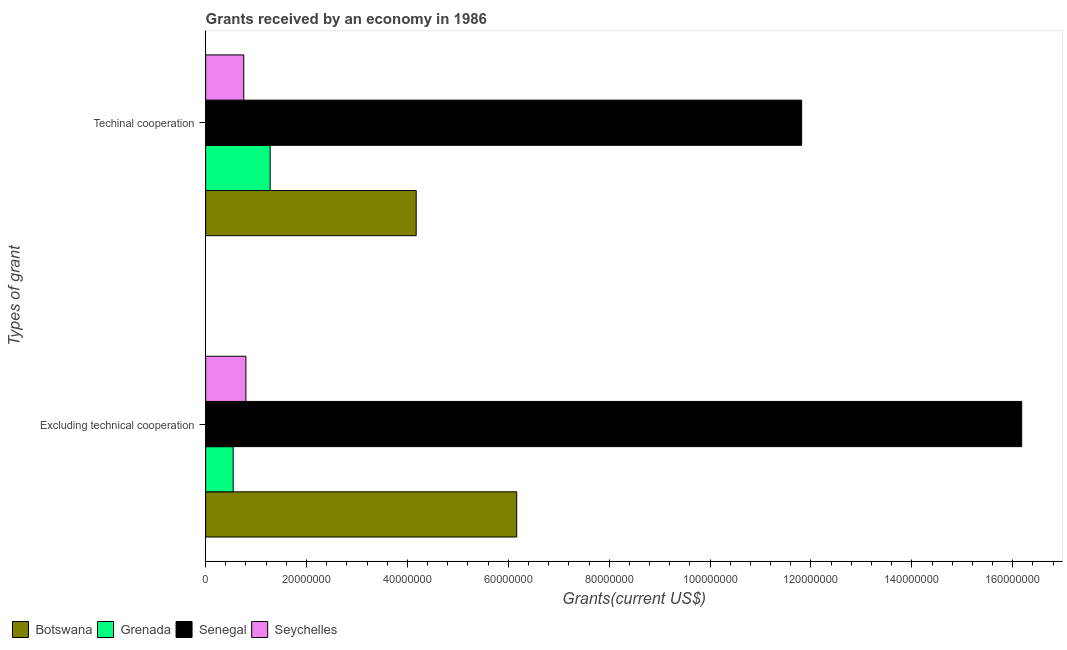How many different coloured bars are there?
Make the answer very short. 4. How many groups of bars are there?
Ensure brevity in your answer.  2. Are the number of bars on each tick of the Y-axis equal?
Provide a short and direct response. Yes. How many bars are there on the 2nd tick from the top?
Ensure brevity in your answer.  4. What is the label of the 1st group of bars from the top?
Your answer should be compact. Techinal cooperation. What is the amount of grants received(including technical cooperation) in Grenada?
Offer a terse response. 1.28e+07. Across all countries, what is the maximum amount of grants received(excluding technical cooperation)?
Offer a very short reply. 1.62e+08. Across all countries, what is the minimum amount of grants received(excluding technical cooperation)?
Give a very brief answer. 5.46e+06. In which country was the amount of grants received(including technical cooperation) maximum?
Provide a short and direct response. Senegal. In which country was the amount of grants received(excluding technical cooperation) minimum?
Your answer should be compact. Grenada. What is the total amount of grants received(including technical cooperation) in the graph?
Your response must be concise. 1.80e+08. What is the difference between the amount of grants received(excluding technical cooperation) in Grenada and that in Senegal?
Offer a terse response. -1.56e+08. What is the difference between the amount of grants received(excluding technical cooperation) in Grenada and the amount of grants received(including technical cooperation) in Senegal?
Your response must be concise. -1.13e+08. What is the average amount of grants received(excluding technical cooperation) per country?
Make the answer very short. 5.92e+07. What is the difference between the amount of grants received(including technical cooperation) and amount of grants received(excluding technical cooperation) in Seychelles?
Provide a short and direct response. -4.20e+05. What is the ratio of the amount of grants received(including technical cooperation) in Seychelles to that in Grenada?
Keep it short and to the point. 0.59. Is the amount of grants received(excluding technical cooperation) in Botswana less than that in Grenada?
Make the answer very short. No. In how many countries, is the amount of grants received(excluding technical cooperation) greater than the average amount of grants received(excluding technical cooperation) taken over all countries?
Ensure brevity in your answer.  2. What does the 3rd bar from the top in Excluding technical cooperation represents?
Your response must be concise. Grenada. What does the 4th bar from the bottom in Techinal cooperation represents?
Offer a very short reply. Seychelles. How many bars are there?
Keep it short and to the point. 8. Does the graph contain any zero values?
Your response must be concise. No. Does the graph contain grids?
Your response must be concise. No. How many legend labels are there?
Provide a succinct answer. 4. How are the legend labels stacked?
Ensure brevity in your answer.  Horizontal. What is the title of the graph?
Ensure brevity in your answer.  Grants received by an economy in 1986. What is the label or title of the X-axis?
Your answer should be very brief. Grants(current US$). What is the label or title of the Y-axis?
Keep it short and to the point. Types of grant. What is the Grants(current US$) in Botswana in Excluding technical cooperation?
Keep it short and to the point. 6.17e+07. What is the Grants(current US$) of Grenada in Excluding technical cooperation?
Provide a short and direct response. 5.46e+06. What is the Grants(current US$) of Senegal in Excluding technical cooperation?
Your response must be concise. 1.62e+08. What is the Grants(current US$) of Seychelles in Excluding technical cooperation?
Your answer should be very brief. 7.98e+06. What is the Grants(current US$) in Botswana in Techinal cooperation?
Ensure brevity in your answer.  4.17e+07. What is the Grants(current US$) in Grenada in Techinal cooperation?
Your answer should be compact. 1.28e+07. What is the Grants(current US$) of Senegal in Techinal cooperation?
Ensure brevity in your answer.  1.18e+08. What is the Grants(current US$) of Seychelles in Techinal cooperation?
Make the answer very short. 7.56e+06. Across all Types of grant, what is the maximum Grants(current US$) in Botswana?
Your response must be concise. 6.17e+07. Across all Types of grant, what is the maximum Grants(current US$) in Grenada?
Offer a terse response. 1.28e+07. Across all Types of grant, what is the maximum Grants(current US$) of Senegal?
Keep it short and to the point. 1.62e+08. Across all Types of grant, what is the maximum Grants(current US$) in Seychelles?
Ensure brevity in your answer.  7.98e+06. Across all Types of grant, what is the minimum Grants(current US$) of Botswana?
Offer a terse response. 4.17e+07. Across all Types of grant, what is the minimum Grants(current US$) of Grenada?
Your answer should be very brief. 5.46e+06. Across all Types of grant, what is the minimum Grants(current US$) in Senegal?
Offer a very short reply. 1.18e+08. Across all Types of grant, what is the minimum Grants(current US$) of Seychelles?
Provide a succinct answer. 7.56e+06. What is the total Grants(current US$) in Botswana in the graph?
Keep it short and to the point. 1.03e+08. What is the total Grants(current US$) of Grenada in the graph?
Your answer should be compact. 1.82e+07. What is the total Grants(current US$) of Senegal in the graph?
Give a very brief answer. 2.80e+08. What is the total Grants(current US$) of Seychelles in the graph?
Give a very brief answer. 1.55e+07. What is the difference between the Grants(current US$) in Botswana in Excluding technical cooperation and that in Techinal cooperation?
Keep it short and to the point. 1.99e+07. What is the difference between the Grants(current US$) of Grenada in Excluding technical cooperation and that in Techinal cooperation?
Make the answer very short. -7.33e+06. What is the difference between the Grants(current US$) of Senegal in Excluding technical cooperation and that in Techinal cooperation?
Offer a very short reply. 4.36e+07. What is the difference between the Grants(current US$) in Botswana in Excluding technical cooperation and the Grants(current US$) in Grenada in Techinal cooperation?
Your response must be concise. 4.89e+07. What is the difference between the Grants(current US$) in Botswana in Excluding technical cooperation and the Grants(current US$) in Senegal in Techinal cooperation?
Provide a short and direct response. -5.65e+07. What is the difference between the Grants(current US$) of Botswana in Excluding technical cooperation and the Grants(current US$) of Seychelles in Techinal cooperation?
Provide a succinct answer. 5.41e+07. What is the difference between the Grants(current US$) of Grenada in Excluding technical cooperation and the Grants(current US$) of Senegal in Techinal cooperation?
Ensure brevity in your answer.  -1.13e+08. What is the difference between the Grants(current US$) of Grenada in Excluding technical cooperation and the Grants(current US$) of Seychelles in Techinal cooperation?
Give a very brief answer. -2.10e+06. What is the difference between the Grants(current US$) of Senegal in Excluding technical cooperation and the Grants(current US$) of Seychelles in Techinal cooperation?
Give a very brief answer. 1.54e+08. What is the average Grants(current US$) in Botswana per Types of grant?
Your answer should be compact. 5.17e+07. What is the average Grants(current US$) in Grenada per Types of grant?
Make the answer very short. 9.12e+06. What is the average Grants(current US$) in Senegal per Types of grant?
Your response must be concise. 1.40e+08. What is the average Grants(current US$) of Seychelles per Types of grant?
Keep it short and to the point. 7.77e+06. What is the difference between the Grants(current US$) of Botswana and Grants(current US$) of Grenada in Excluding technical cooperation?
Provide a short and direct response. 5.62e+07. What is the difference between the Grants(current US$) in Botswana and Grants(current US$) in Senegal in Excluding technical cooperation?
Your answer should be very brief. -1.00e+08. What is the difference between the Grants(current US$) of Botswana and Grants(current US$) of Seychelles in Excluding technical cooperation?
Make the answer very short. 5.37e+07. What is the difference between the Grants(current US$) in Grenada and Grants(current US$) in Senegal in Excluding technical cooperation?
Your answer should be very brief. -1.56e+08. What is the difference between the Grants(current US$) of Grenada and Grants(current US$) of Seychelles in Excluding technical cooperation?
Make the answer very short. -2.52e+06. What is the difference between the Grants(current US$) in Senegal and Grants(current US$) in Seychelles in Excluding technical cooperation?
Ensure brevity in your answer.  1.54e+08. What is the difference between the Grants(current US$) in Botswana and Grants(current US$) in Grenada in Techinal cooperation?
Keep it short and to the point. 2.90e+07. What is the difference between the Grants(current US$) in Botswana and Grants(current US$) in Senegal in Techinal cooperation?
Provide a succinct answer. -7.64e+07. What is the difference between the Grants(current US$) in Botswana and Grants(current US$) in Seychelles in Techinal cooperation?
Offer a terse response. 3.42e+07. What is the difference between the Grants(current US$) of Grenada and Grants(current US$) of Senegal in Techinal cooperation?
Your answer should be compact. -1.05e+08. What is the difference between the Grants(current US$) of Grenada and Grants(current US$) of Seychelles in Techinal cooperation?
Provide a short and direct response. 5.23e+06. What is the difference between the Grants(current US$) in Senegal and Grants(current US$) in Seychelles in Techinal cooperation?
Give a very brief answer. 1.11e+08. What is the ratio of the Grants(current US$) in Botswana in Excluding technical cooperation to that in Techinal cooperation?
Ensure brevity in your answer.  1.48. What is the ratio of the Grants(current US$) in Grenada in Excluding technical cooperation to that in Techinal cooperation?
Give a very brief answer. 0.43. What is the ratio of the Grants(current US$) of Senegal in Excluding technical cooperation to that in Techinal cooperation?
Your answer should be very brief. 1.37. What is the ratio of the Grants(current US$) in Seychelles in Excluding technical cooperation to that in Techinal cooperation?
Offer a very short reply. 1.06. What is the difference between the highest and the second highest Grants(current US$) in Botswana?
Give a very brief answer. 1.99e+07. What is the difference between the highest and the second highest Grants(current US$) in Grenada?
Make the answer very short. 7.33e+06. What is the difference between the highest and the second highest Grants(current US$) in Senegal?
Your answer should be very brief. 4.36e+07. What is the difference between the highest and the lowest Grants(current US$) in Botswana?
Your answer should be compact. 1.99e+07. What is the difference between the highest and the lowest Grants(current US$) of Grenada?
Offer a very short reply. 7.33e+06. What is the difference between the highest and the lowest Grants(current US$) of Senegal?
Keep it short and to the point. 4.36e+07. 